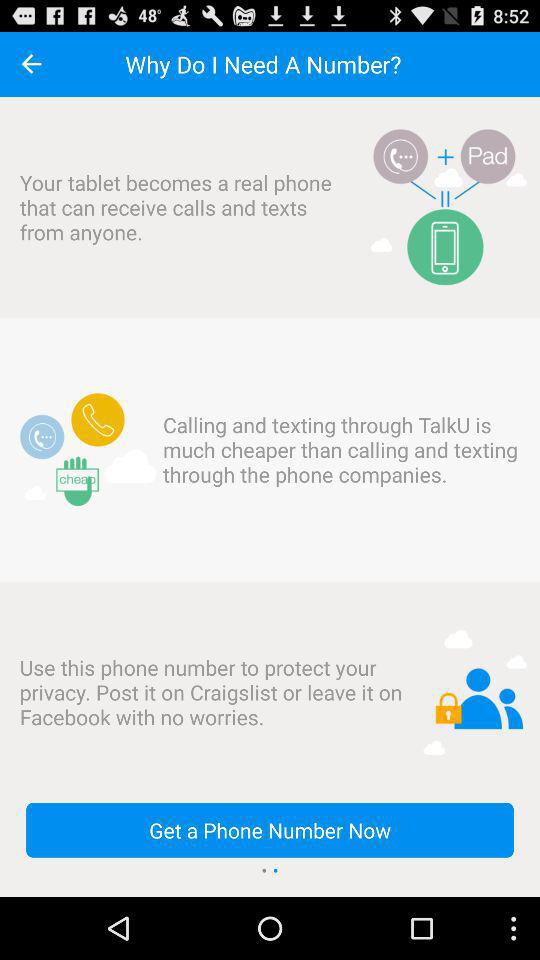How is a tablet useful?
When the provided information is insufficient, respond with <no answer>. <no answer> 